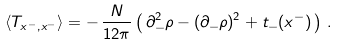<formula> <loc_0><loc_0><loc_500><loc_500>\langle T _ { x ^ { - } , x ^ { - } } \rangle = - \, \frac { N } { 1 2 \pi } \left ( \, \partial _ { - } ^ { 2 } \rho - ( \partial _ { - } \rho ) ^ { 2 } + t _ { - } ( x ^ { - } ) \, \right ) \, .</formula> 